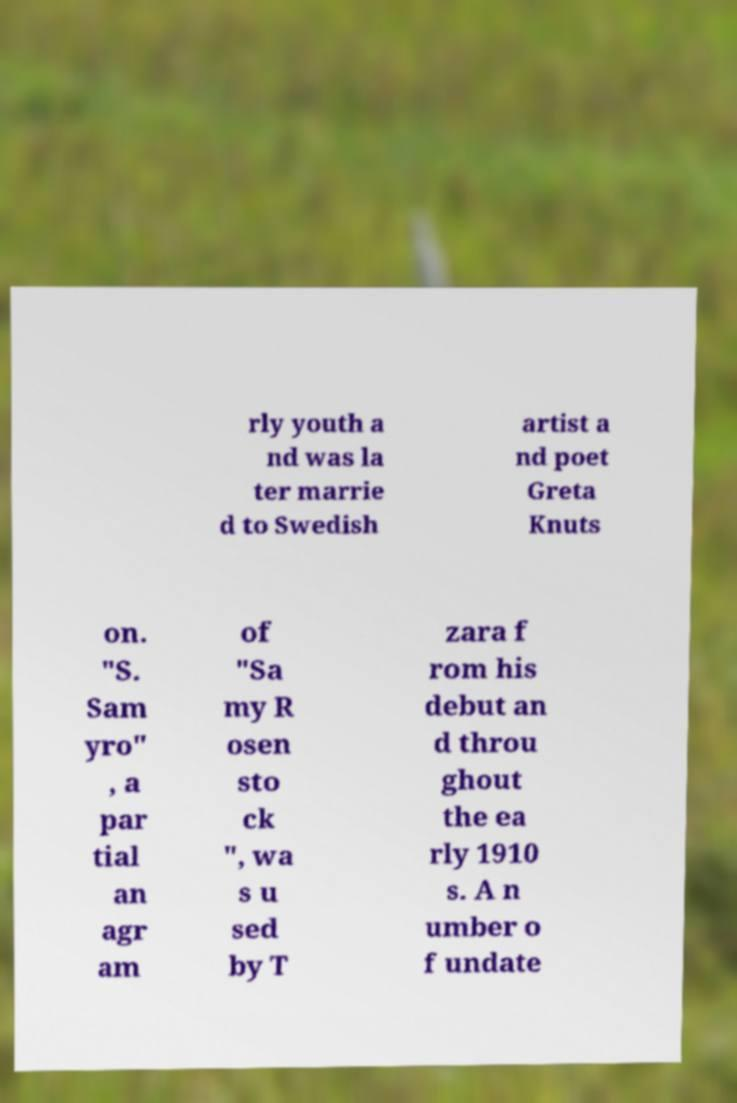Could you extract and type out the text from this image? rly youth a nd was la ter marrie d to Swedish artist a nd poet Greta Knuts on. "S. Sam yro" , a par tial an agr am of "Sa my R osen sto ck ", wa s u sed by T zara f rom his debut an d throu ghout the ea rly 1910 s. A n umber o f undate 